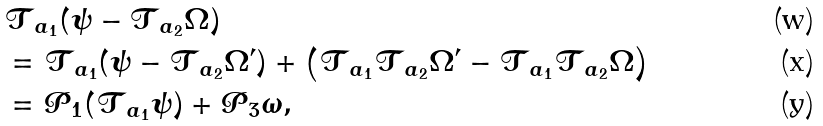<formula> <loc_0><loc_0><loc_500><loc_500>& \mathcal { T } _ { a _ { 1 } } ( \psi - \mathcal { T } _ { a _ { 2 } } \Omega ) \\ & = \mathcal { T } _ { a _ { 1 } } ( \psi - \mathcal { T } _ { a _ { 2 } } \Omega ^ { \prime } ) + \left ( \mathcal { T } _ { a _ { 1 } } \mathcal { T } _ { a _ { 2 } } \Omega ^ { \prime } - \mathcal { T } _ { a _ { 1 } } \mathcal { T } _ { a _ { 2 } } \Omega \right ) \\ & = \mathcal { P } _ { 1 } ( \mathcal { T } _ { a _ { 1 } } \psi ) + \mathcal { P } _ { 3 } \omega ,</formula> 